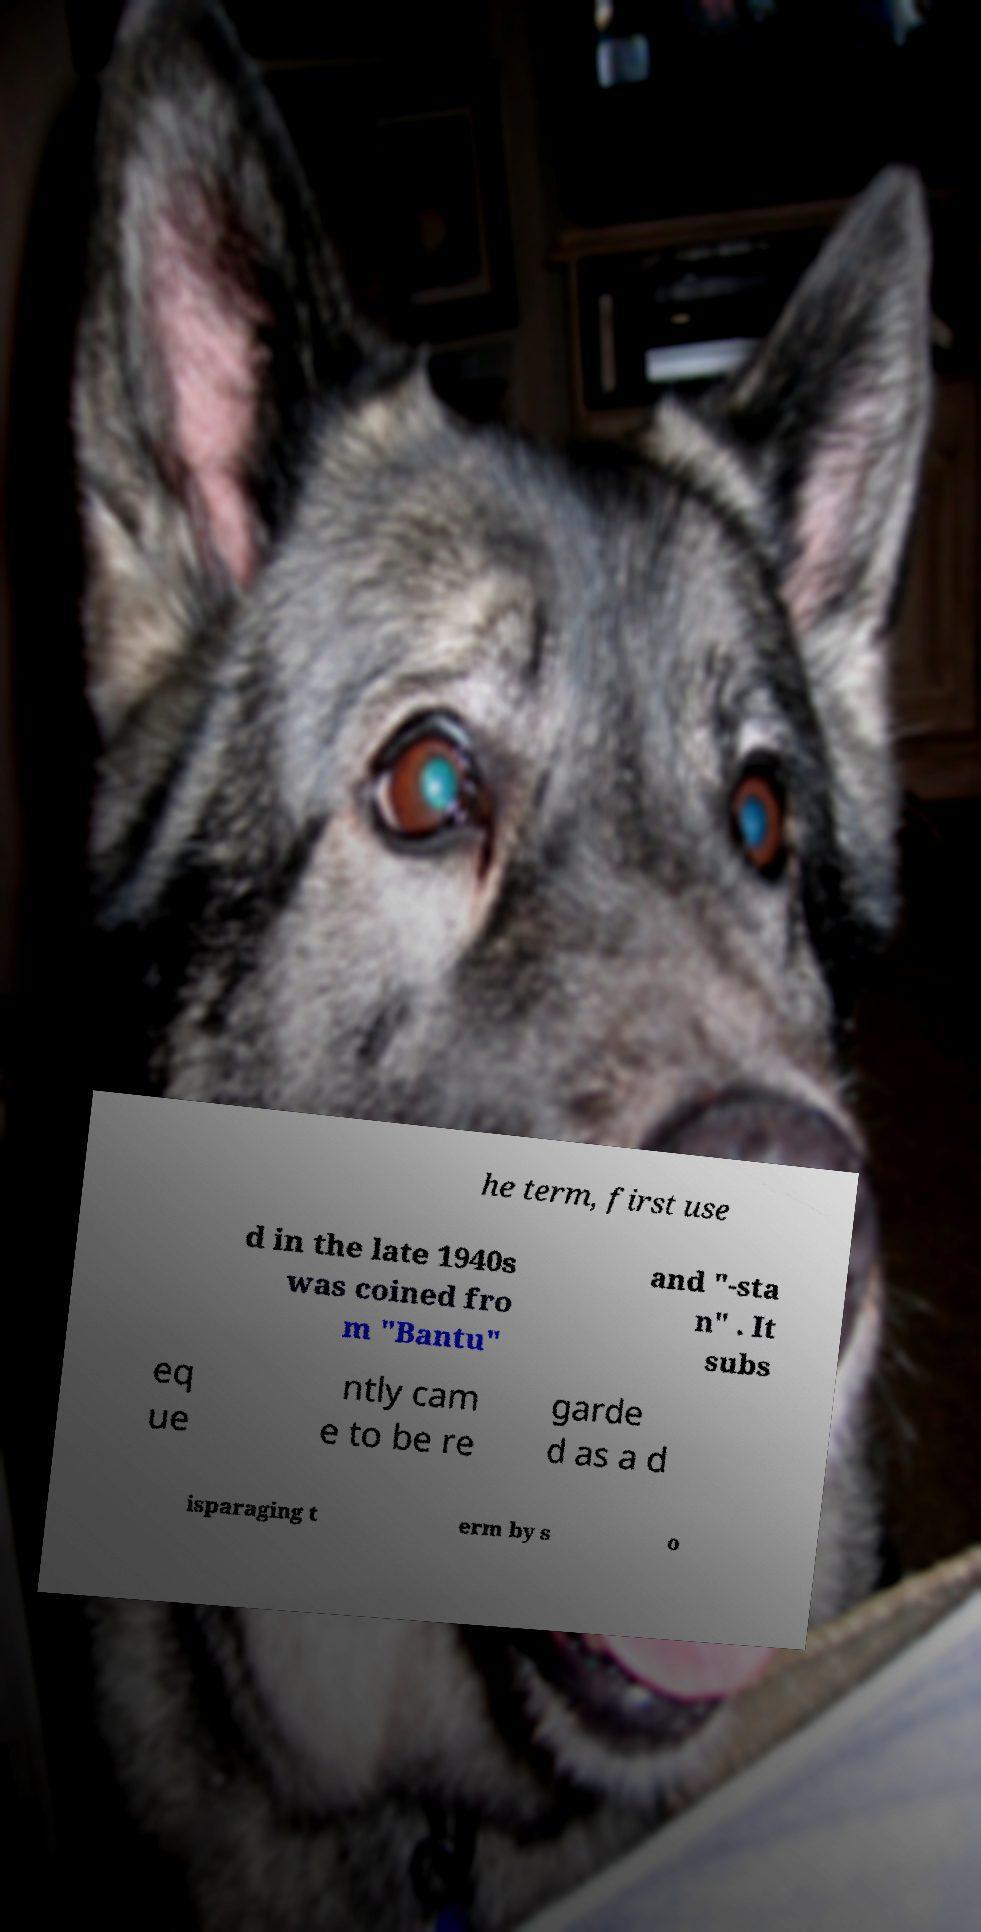What messages or text are displayed in this image? I need them in a readable, typed format. he term, first use d in the late 1940s was coined fro m "Bantu" and "-sta n" . It subs eq ue ntly cam e to be re garde d as a d isparaging t erm by s o 